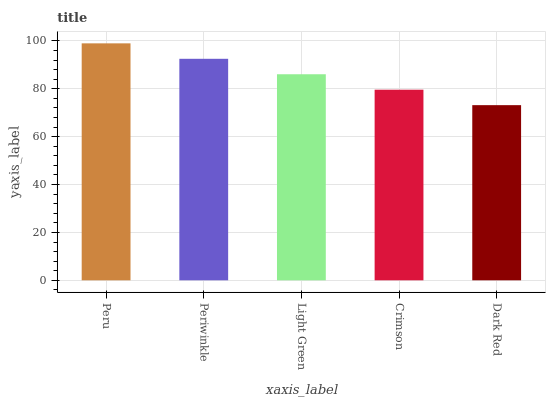Is Dark Red the minimum?
Answer yes or no. Yes. Is Peru the maximum?
Answer yes or no. Yes. Is Periwinkle the minimum?
Answer yes or no. No. Is Periwinkle the maximum?
Answer yes or no. No. Is Peru greater than Periwinkle?
Answer yes or no. Yes. Is Periwinkle less than Peru?
Answer yes or no. Yes. Is Periwinkle greater than Peru?
Answer yes or no. No. Is Peru less than Periwinkle?
Answer yes or no. No. Is Light Green the high median?
Answer yes or no. Yes. Is Light Green the low median?
Answer yes or no. Yes. Is Crimson the high median?
Answer yes or no. No. Is Periwinkle the low median?
Answer yes or no. No. 